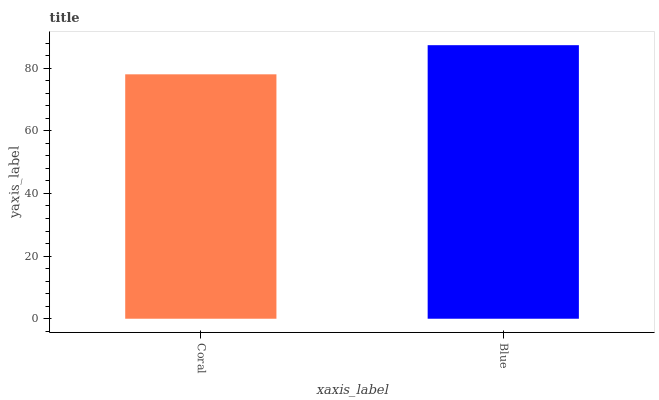Is Coral the minimum?
Answer yes or no. Yes. Is Blue the maximum?
Answer yes or no. Yes. Is Blue the minimum?
Answer yes or no. No. Is Blue greater than Coral?
Answer yes or no. Yes. Is Coral less than Blue?
Answer yes or no. Yes. Is Coral greater than Blue?
Answer yes or no. No. Is Blue less than Coral?
Answer yes or no. No. Is Blue the high median?
Answer yes or no. Yes. Is Coral the low median?
Answer yes or no. Yes. Is Coral the high median?
Answer yes or no. No. Is Blue the low median?
Answer yes or no. No. 